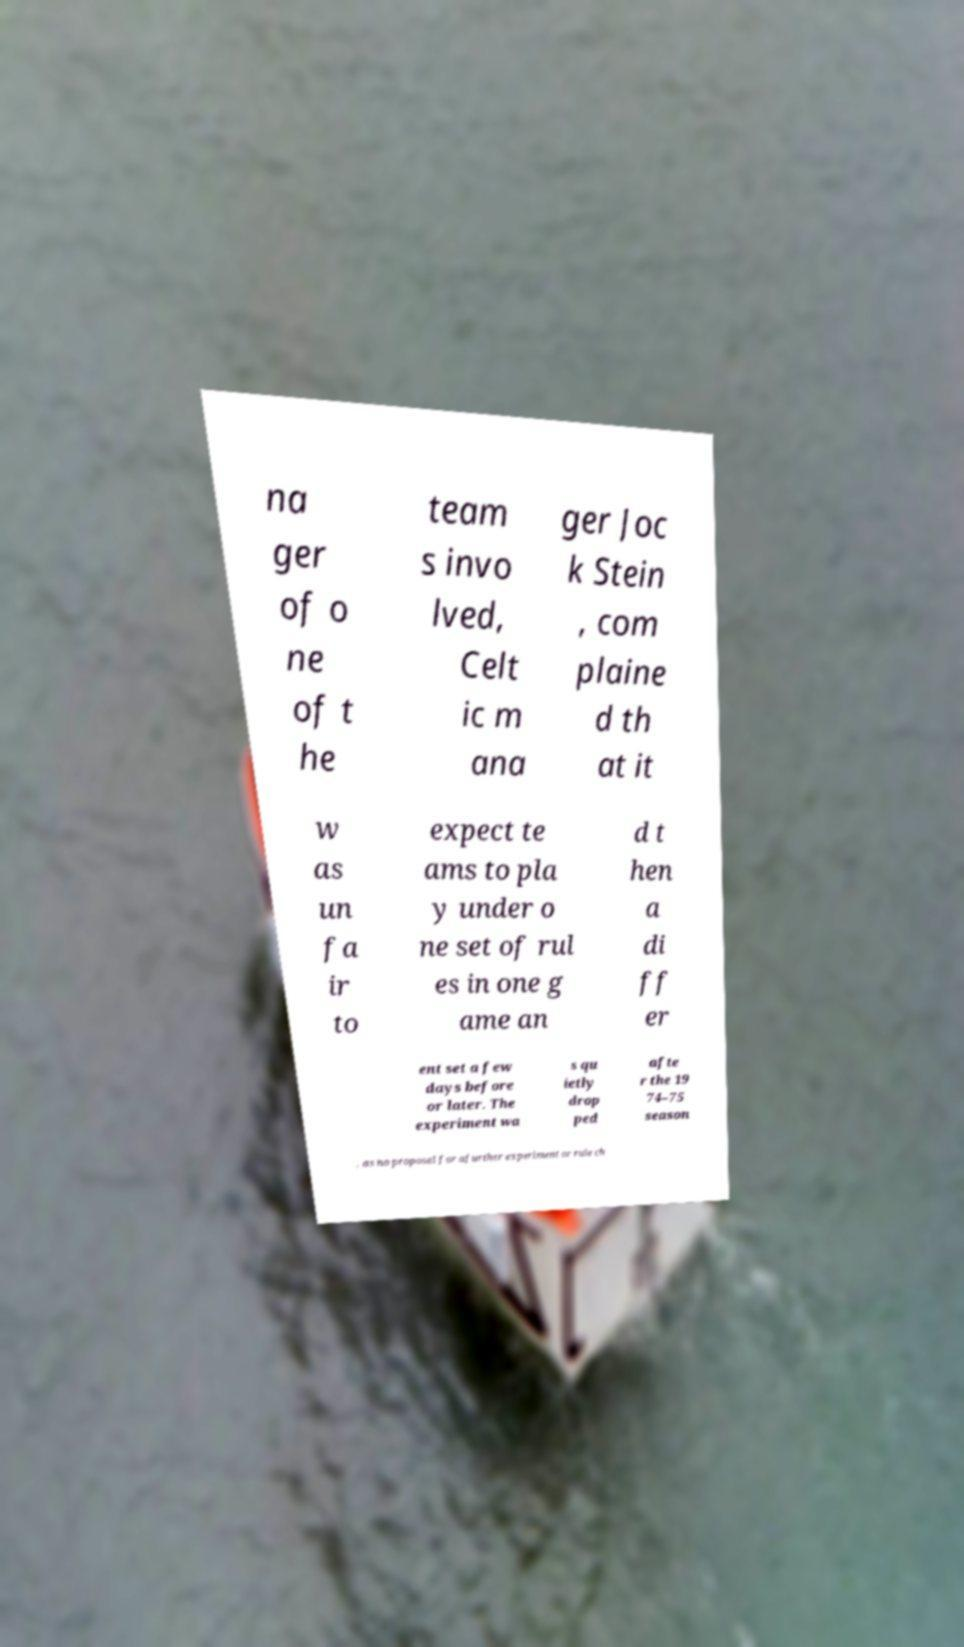Could you extract and type out the text from this image? na ger of o ne of t he team s invo lved, Celt ic m ana ger Joc k Stein , com plaine d th at it w as un fa ir to expect te ams to pla y under o ne set of rul es in one g ame an d t hen a di ff er ent set a few days before or later. The experiment wa s qu ietly drop ped afte r the 19 74–75 season , as no proposal for afurther experiment or rule ch 